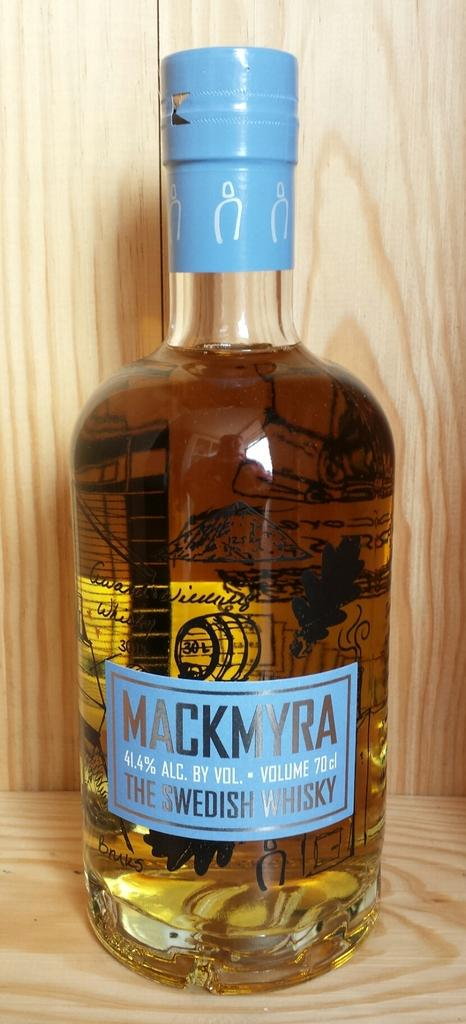<image>
Relay a brief, clear account of the picture shown. A bottle of Mackmyra Swedish whiskey with a blue wrap on top. 